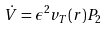Convert formula to latex. <formula><loc_0><loc_0><loc_500><loc_500>\dot { V } = \epsilon ^ { 2 } v _ { T } ( r ) P _ { 2 }</formula> 